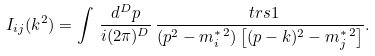<formula> <loc_0><loc_0><loc_500><loc_500>I _ { i j } ( k ^ { 2 } ) = \int \, \frac { d ^ { D } p } { i ( 2 \pi ) ^ { D } } \, \frac { \ t r s 1 } { ( p ^ { 2 } - m _ { i } ^ { * \, 2 } ) \left [ ( p - k ) ^ { 2 } - m _ { j } ^ { * \, 2 } \right ] } .</formula> 